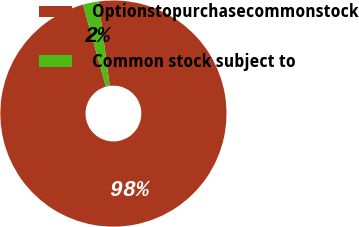<chart> <loc_0><loc_0><loc_500><loc_500><pie_chart><fcel>Optionstopurchasecommonstock<fcel>Common stock subject to<nl><fcel>97.77%<fcel>2.23%<nl></chart> 